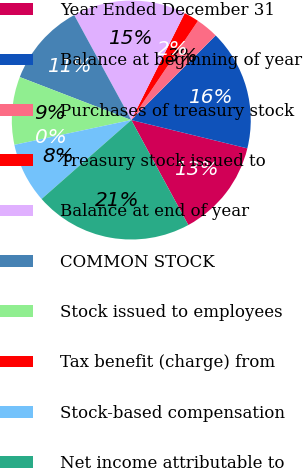<chart> <loc_0><loc_0><loc_500><loc_500><pie_chart><fcel>Year Ended December 31<fcel>Balance at beginning of year<fcel>Purchases of treasury stock<fcel>Treasury stock issued to<fcel>Balance at end of year<fcel>COMMON STOCK<fcel>Stock issued to employees<fcel>Tax benefit (charge) from<fcel>Stock-based compensation<fcel>Net income attributable to<nl><fcel>13.27%<fcel>16.33%<fcel>3.06%<fcel>2.04%<fcel>15.31%<fcel>11.22%<fcel>9.18%<fcel>0.0%<fcel>8.16%<fcel>21.43%<nl></chart> 